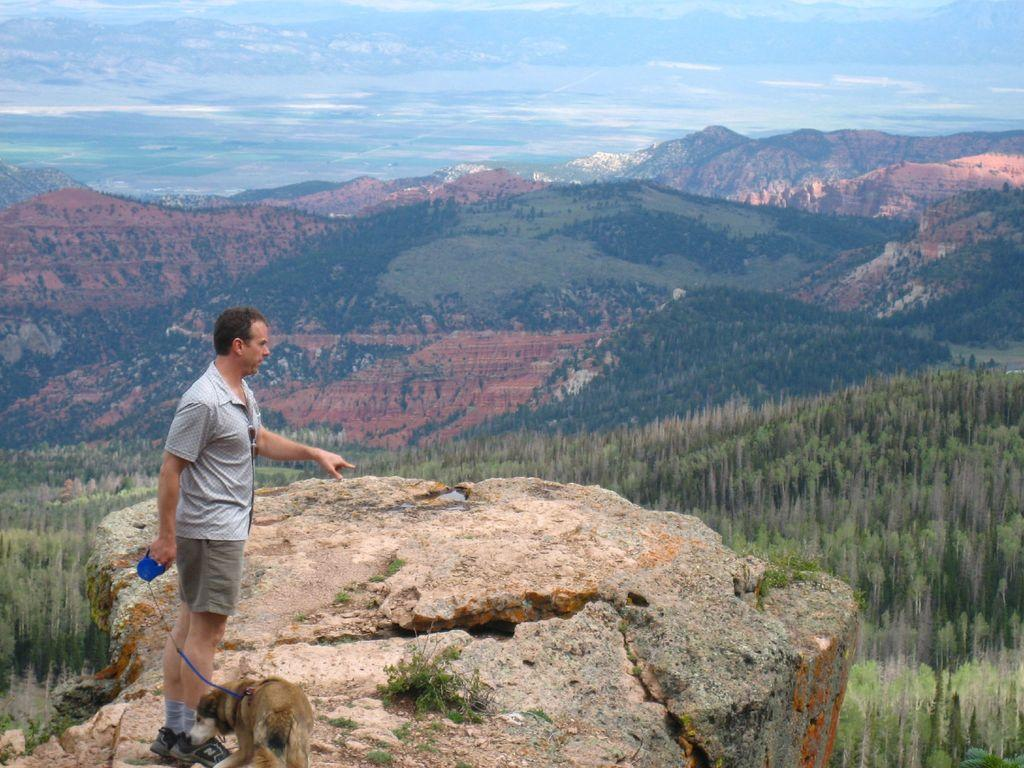What is the man doing in the image? The man is standing on a mountain in the image. Does the man have any companions in the image? Yes, the man has a dog with him. What is the color of the sky in the image? The sky is blue in the image. What type of powder can be seen on the man's hands in the image? There is no powder visible on the man's hands in the image. Is the man in the wilderness in the image? The provided facts do not specify whether the man is in the wilderness or not, but we can see that he is standing on a mountain. 